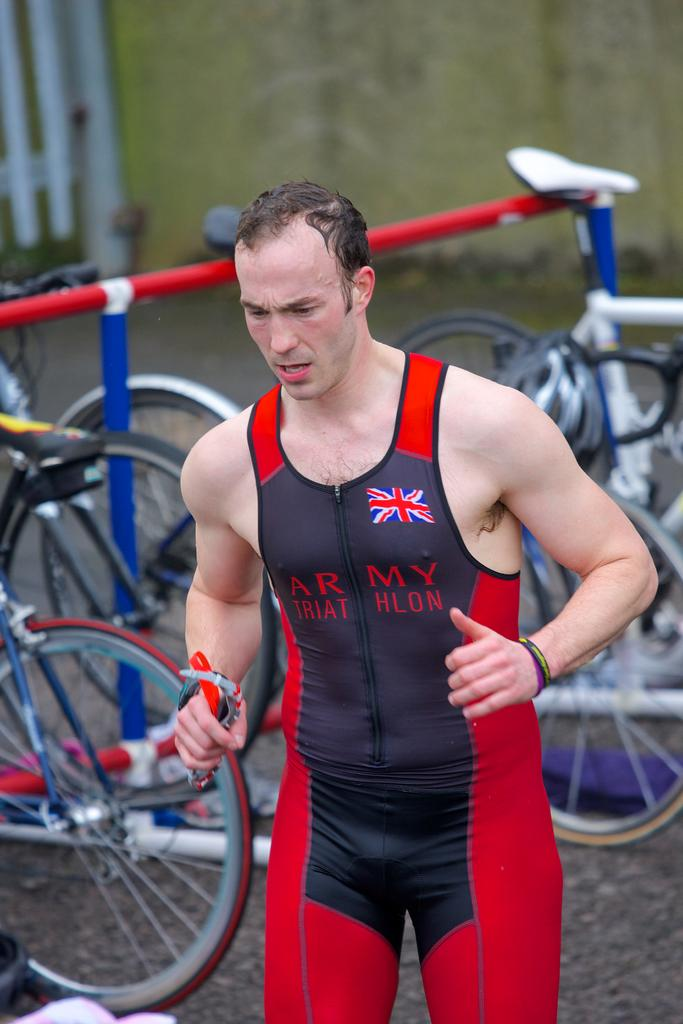Provide a one-sentence caption for the provided image. A man wearing red and blue army triathlon bike tights is walking away from the bikes. 